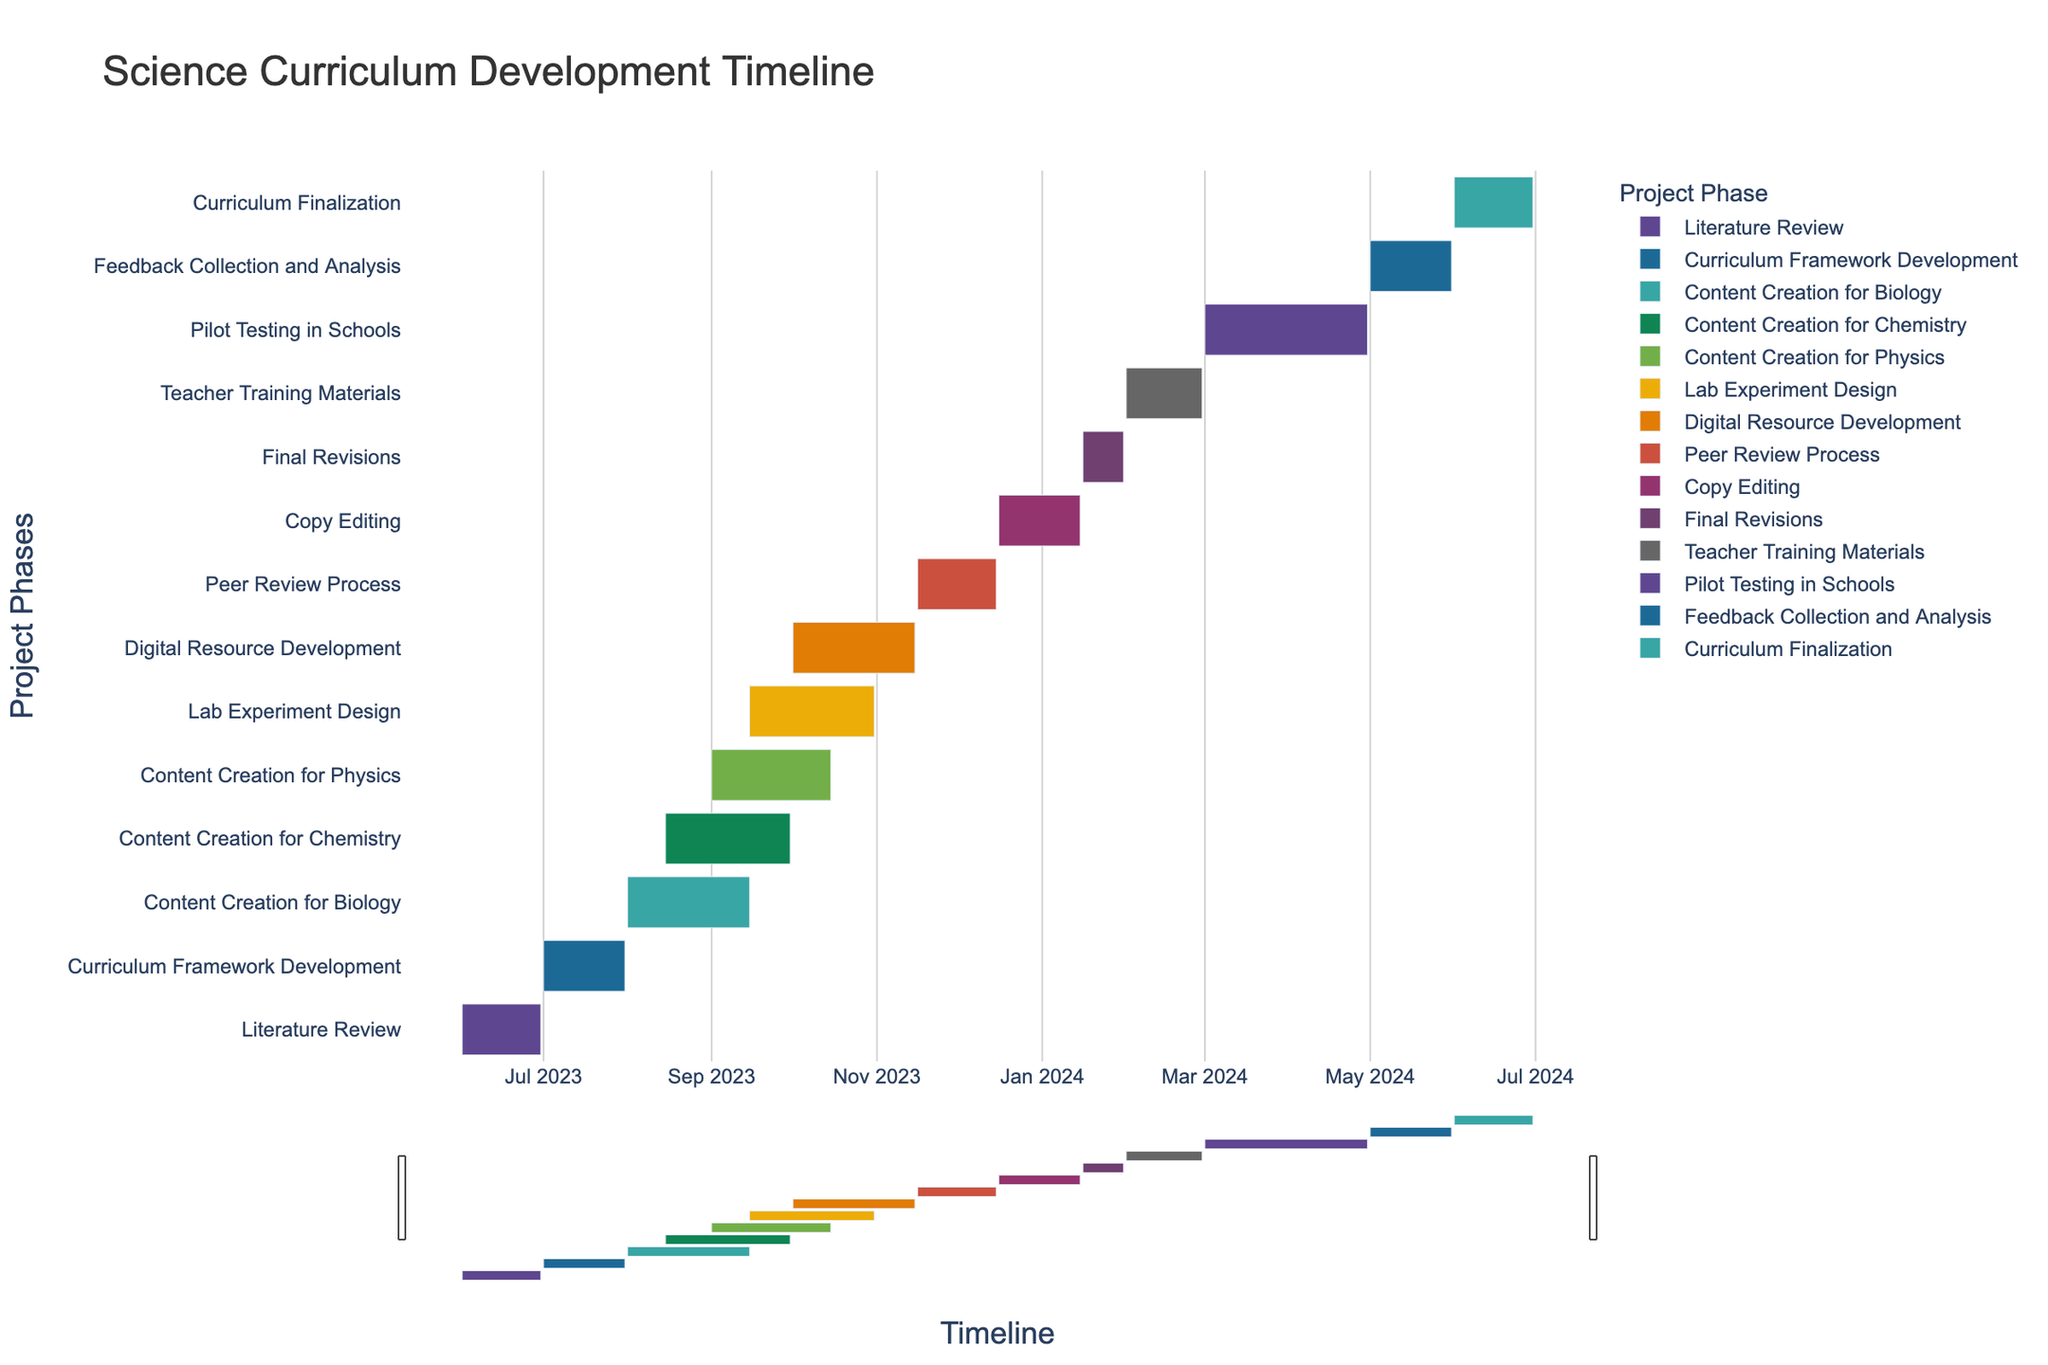What is the title of the chart? The title is usually found at the top of the chart. In this Gantt chart, it is labeled clearly.
Answer: Science Curriculum Development Timeline What is the duration of the Literature Review phase? To find the duration, subtract the start date from the end date for the Literature Review phase. It starts on June 1, 2023, and ends on June 30, 2023. The duration is 30 days.
Answer: 30 days Which phase runs the longest, and what is its duration? By looking at the length of the bars, the Pilot Testing in Schools phase runs the longest. It starts on March 1, 2024, and ends on April 30, 2024. The duration is 61 days.
Answer: Pilot Testing in Schools, 61 days What phases overlap with the Content Creation for Biology phase? Identify the start and end dates for Content Creation for Biology. Then, check other phases with dates between August 1, 2023, and September 15, 2023. The phases are Content Creation for Chemistry, Content Creation for Physics, and Lab Experiment Design.
Answer: Content Creation for Chemistry, Content Creation for Physics, Lab Experiment Design Which phases occur simultaneously? Look for tasks that have overlapping timelines. The phases Content Creation for Biology, Content Creation for Chemistry, and Content Creation for Physics all overlap at some point.
Answer: Content Creation for Biology, Content Creation for Chemistry, Content Creation for Physics How many tasks start in September 2023? Count the tasks that have their start date in September 2023. The tasks are Content Creation for Physics and Lab Experiment Design.
Answer: 2 tasks Which phase starts immediately after Digital Resource Development ends? Find the end date of Digital Resource Development, which is November 15, 2023, and see which task starts next. The Peer Review Process starts on November 16, 2023.
Answer: Peer Review Process When does the Pilot Testing in Schools phase end? Check the end date listed for the Pilot Testing in Schools phase. It ends on April 30, 2024.
Answer: April 30, 2024 What is the total duration from the start of the first task to the end of the last task? Identify the start date of the first task (June 1, 2023) and the end date of the last task (June 30, 2024). The total duration is from June 1, 2023, to June 30, 2024, which is 396 days.
Answer: 396 days 